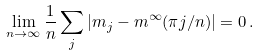<formula> <loc_0><loc_0><loc_500><loc_500>\lim _ { n \to \infty } \frac { 1 } { n } \sum _ { j } \left | m _ { j } - m ^ { \infty } ( \pi j / n ) \right | = 0 \, .</formula> 